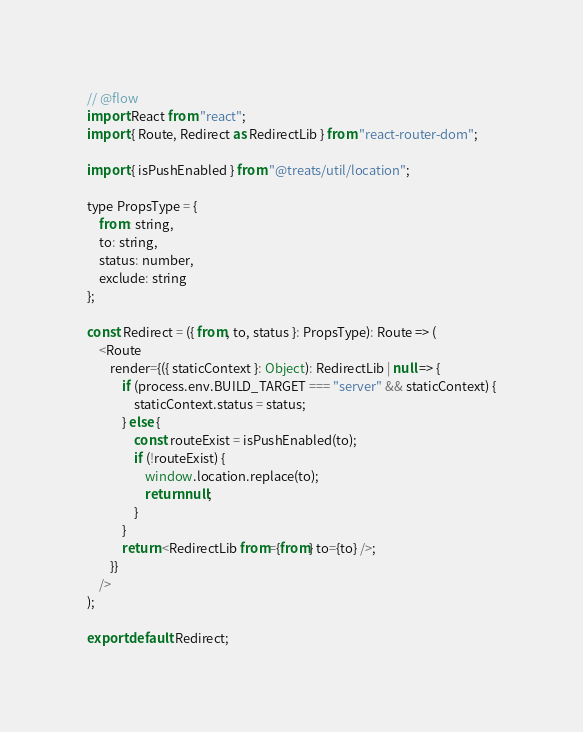<code> <loc_0><loc_0><loc_500><loc_500><_JavaScript_>// @flow
import React from "react";
import { Route, Redirect as RedirectLib } from "react-router-dom";

import { isPushEnabled } from "@treats/util/location";

type PropsType = {
    from: string,
    to: string,
    status: number,
    exclude: string
};

const Redirect = ({ from, to, status }: PropsType): Route => (
    <Route
        render={({ staticContext }: Object): RedirectLib | null => {
            if (process.env.BUILD_TARGET === "server" && staticContext) {
                staticContext.status = status;
            } else {
                const routeExist = isPushEnabled(to);
                if (!routeExist) {
                    window.location.replace(to);
                    return null;
                }
            }
            return <RedirectLib from={from} to={to} />;
        }}
    />
);

export default Redirect;
</code> 